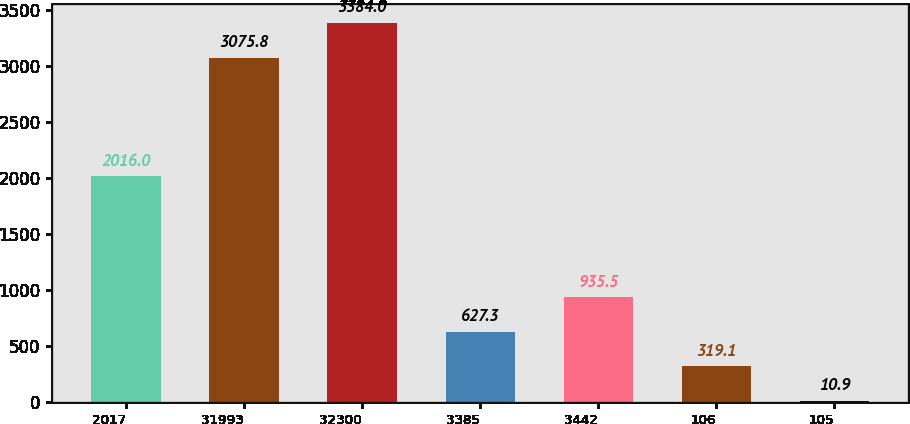Convert chart to OTSL. <chart><loc_0><loc_0><loc_500><loc_500><bar_chart><fcel>2017<fcel>31993<fcel>32300<fcel>3385<fcel>3442<fcel>106<fcel>105<nl><fcel>2016<fcel>3075.8<fcel>3384<fcel>627.3<fcel>935.5<fcel>319.1<fcel>10.9<nl></chart> 